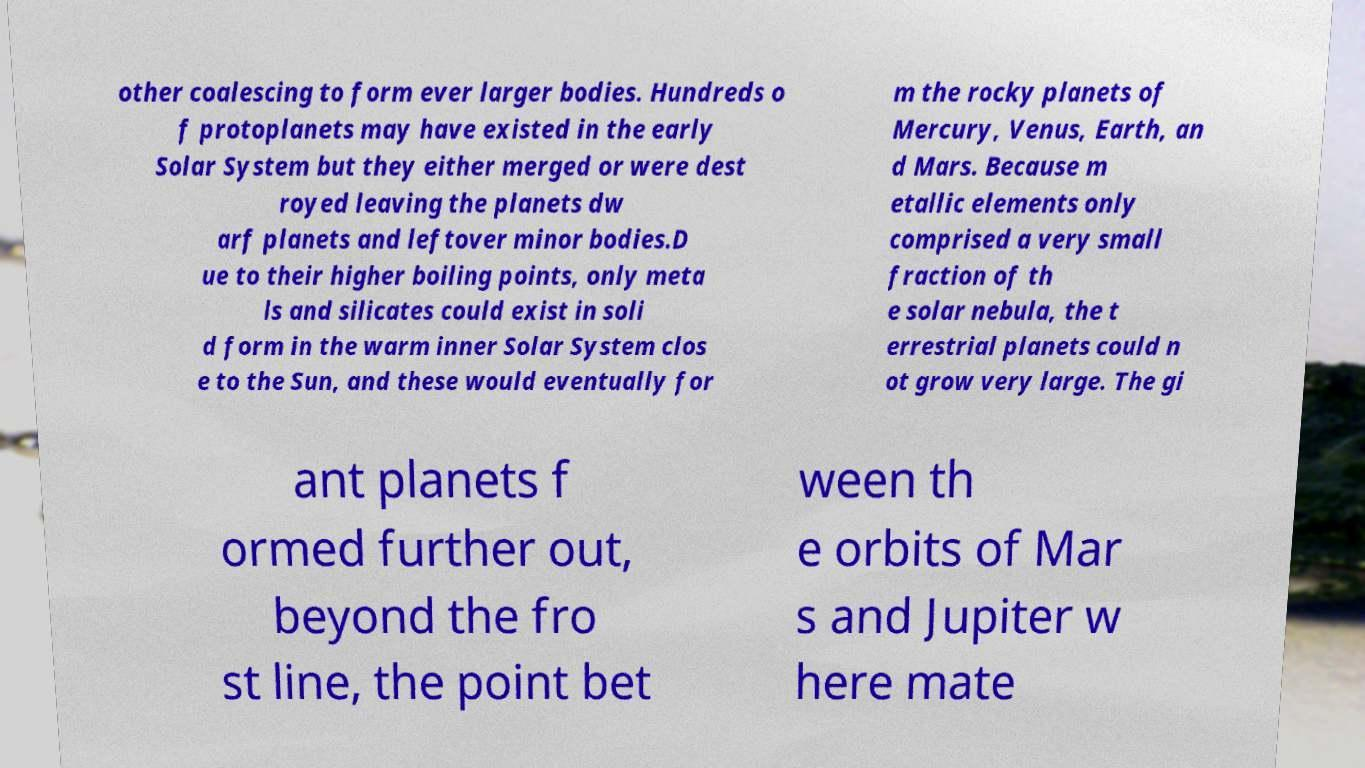For documentation purposes, I need the text within this image transcribed. Could you provide that? other coalescing to form ever larger bodies. Hundreds o f protoplanets may have existed in the early Solar System but they either merged or were dest royed leaving the planets dw arf planets and leftover minor bodies.D ue to their higher boiling points, only meta ls and silicates could exist in soli d form in the warm inner Solar System clos e to the Sun, and these would eventually for m the rocky planets of Mercury, Venus, Earth, an d Mars. Because m etallic elements only comprised a very small fraction of th e solar nebula, the t errestrial planets could n ot grow very large. The gi ant planets f ormed further out, beyond the fro st line, the point bet ween th e orbits of Mar s and Jupiter w here mate 